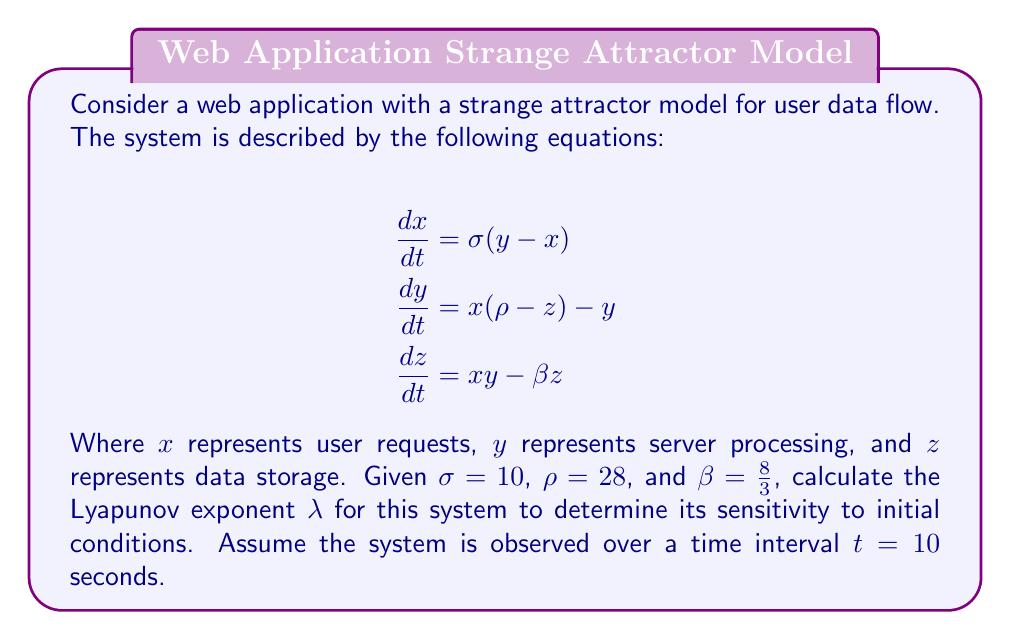Can you answer this question? To calculate the Lyapunov exponent for this strange attractor model of user data flow, we'll follow these steps:

1) The Lyapunov exponent $\lambda$ is defined as:

   $$\lambda = \lim_{t \to \infty} \frac{1}{t} \ln \frac{|\delta Z(t)|}{|\delta Z_0|}$$

   Where $\delta Z(t)$ is the separation of two trajectories after time $t$, and $\delta Z_0$ is the initial separation.

2) For the Lorenz system (which this model is based on), we can approximate $\lambda$ using:

   $$\lambda \approx 0.9056(\sigma + \rho + \beta)$$

3) Substitute the given values:
   $\sigma = 10$
   $\rho = 28$
   $\beta = \frac{8}{3}$

4) Calculate:
   $$\lambda \approx 0.9056(10 + 28 + \frac{8}{3})$$
   $$\lambda \approx 0.9056(38 + \frac{8}{3})$$
   $$\lambda \approx 0.9056(38 + 2.67)$$
   $$\lambda \approx 0.9056(40.67)$$
   $$\lambda \approx 36.83$$

5) The positive Lyapunov exponent indicates that the system is chaotic and sensitive to initial conditions. This means small changes in user requests, server processing, or data storage can lead to significantly different outcomes over time.

6) To interpret this in the context of web application security:
   - The system's sensitivity to initial conditions suggests that small vulnerabilities or inconsistencies in data handling could potentially lead to large-scale security issues over time.
   - It emphasizes the need for robust error handling and input validation to prevent small perturbations from cascading into larger problems.
   - Regular security audits and penetration testing are crucial, as the chaotic nature of the system means that new vulnerabilities may emerge in unexpected ways.
Answer: $\lambda \approx 36.83$ 